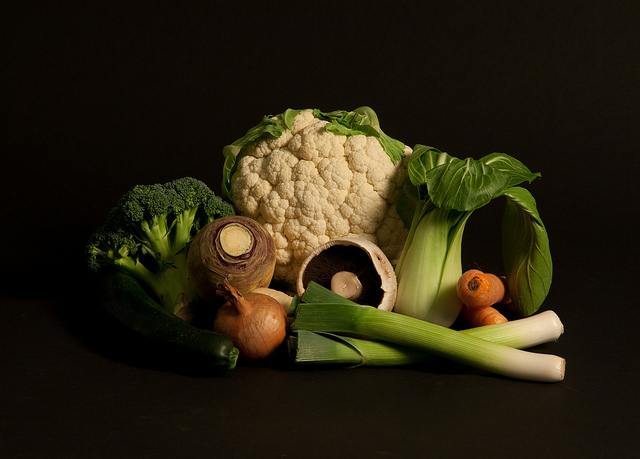Where can these foods be found?
A. fast food
B. bar
C. garden
D. office
Answer with the option's letter from the given choices directly. C 